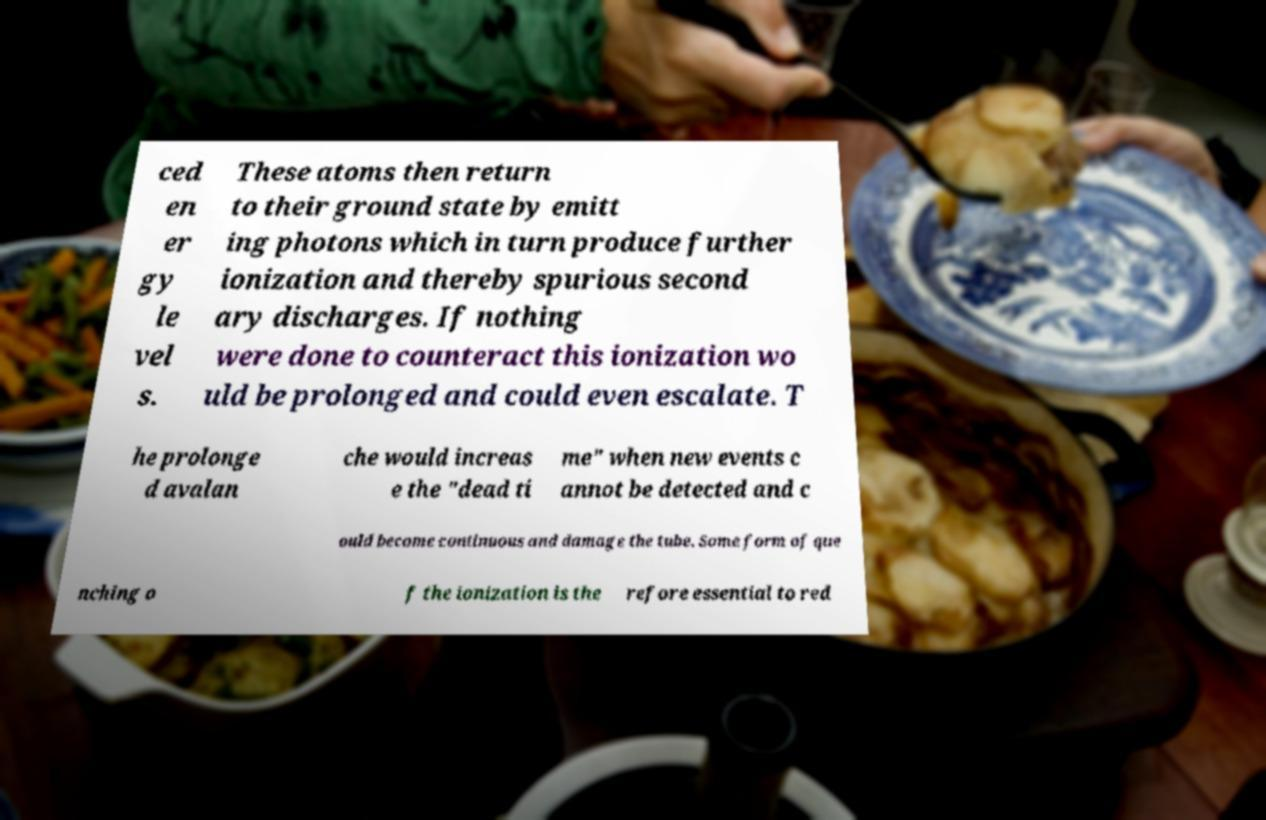Could you assist in decoding the text presented in this image and type it out clearly? ced en er gy le vel s. These atoms then return to their ground state by emitt ing photons which in turn produce further ionization and thereby spurious second ary discharges. If nothing were done to counteract this ionization wo uld be prolonged and could even escalate. T he prolonge d avalan che would increas e the "dead ti me" when new events c annot be detected and c ould become continuous and damage the tube. Some form of que nching o f the ionization is the refore essential to red 